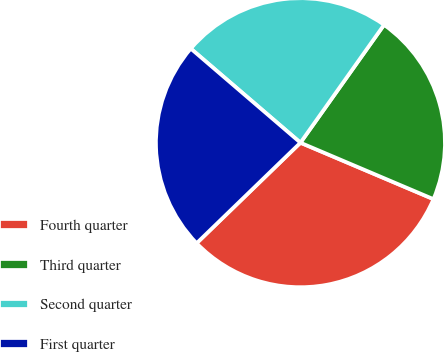Convert chart. <chart><loc_0><loc_0><loc_500><loc_500><pie_chart><fcel>Fourth quarter<fcel>Third quarter<fcel>Second quarter<fcel>First quarter<nl><fcel>31.37%<fcel>21.57%<fcel>23.53%<fcel>23.53%<nl></chart> 